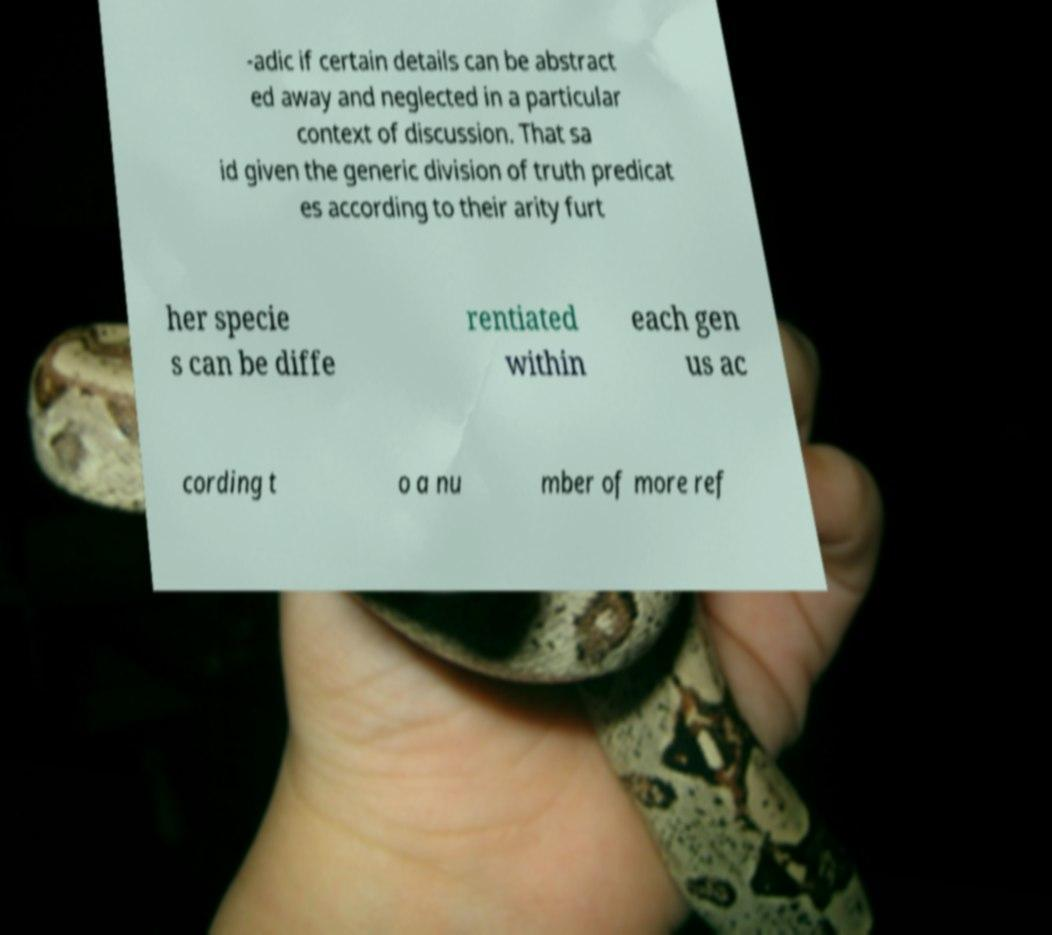Could you assist in decoding the text presented in this image and type it out clearly? -adic if certain details can be abstract ed away and neglected in a particular context of discussion. That sa id given the generic division of truth predicat es according to their arity furt her specie s can be diffe rentiated within each gen us ac cording t o a nu mber of more ref 